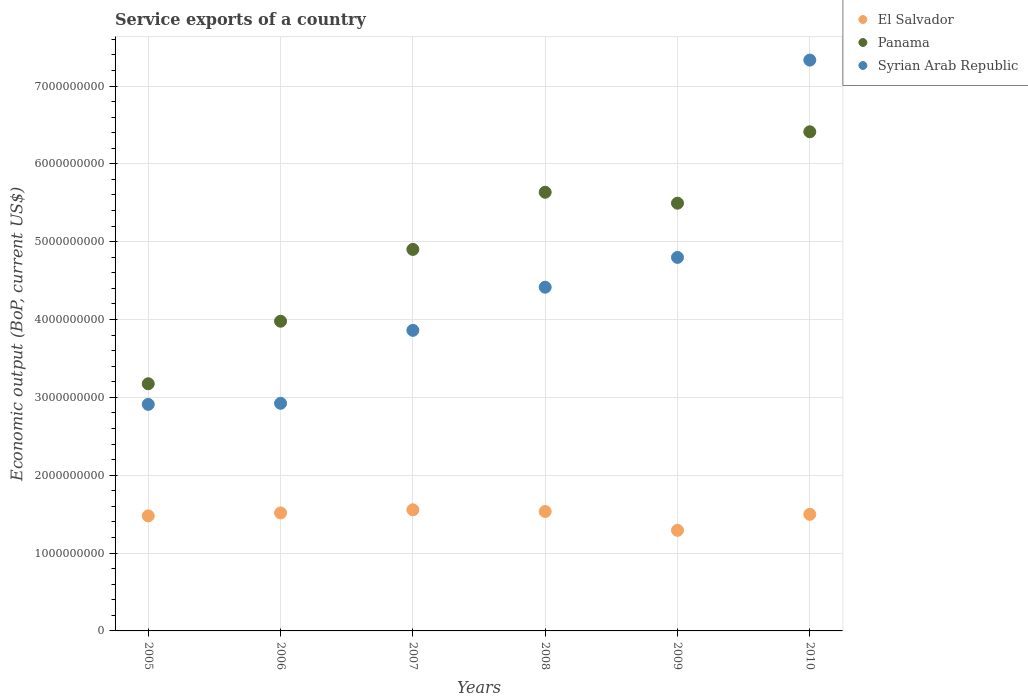Is the number of dotlines equal to the number of legend labels?
Provide a short and direct response. Yes. What is the service exports in Syrian Arab Republic in 2006?
Your response must be concise. 2.92e+09. Across all years, what is the maximum service exports in Syrian Arab Republic?
Keep it short and to the point. 7.33e+09. Across all years, what is the minimum service exports in Panama?
Your answer should be compact. 3.18e+09. What is the total service exports in Panama in the graph?
Keep it short and to the point. 2.96e+1. What is the difference between the service exports in Syrian Arab Republic in 2005 and that in 2010?
Your answer should be very brief. -4.42e+09. What is the difference between the service exports in Syrian Arab Republic in 2006 and the service exports in Panama in 2008?
Keep it short and to the point. -2.71e+09. What is the average service exports in El Salvador per year?
Offer a terse response. 1.48e+09. In the year 2006, what is the difference between the service exports in Syrian Arab Republic and service exports in Panama?
Offer a very short reply. -1.05e+09. What is the ratio of the service exports in Syrian Arab Republic in 2006 to that in 2009?
Keep it short and to the point. 0.61. Is the service exports in Panama in 2005 less than that in 2006?
Keep it short and to the point. Yes. What is the difference between the highest and the second highest service exports in Panama?
Make the answer very short. 7.77e+08. What is the difference between the highest and the lowest service exports in El Salvador?
Offer a very short reply. 2.63e+08. Is the sum of the service exports in Syrian Arab Republic in 2006 and 2008 greater than the maximum service exports in El Salvador across all years?
Your response must be concise. Yes. Does the service exports in El Salvador monotonically increase over the years?
Provide a short and direct response. No. Is the service exports in El Salvador strictly greater than the service exports in Syrian Arab Republic over the years?
Your answer should be very brief. No. Is the service exports in Panama strictly less than the service exports in Syrian Arab Republic over the years?
Keep it short and to the point. No. How many dotlines are there?
Ensure brevity in your answer.  3. What is the difference between two consecutive major ticks on the Y-axis?
Provide a succinct answer. 1.00e+09. Are the values on the major ticks of Y-axis written in scientific E-notation?
Keep it short and to the point. No. How are the legend labels stacked?
Your answer should be compact. Vertical. What is the title of the graph?
Your response must be concise. Service exports of a country. What is the label or title of the Y-axis?
Your answer should be very brief. Economic output (BoP, current US$). What is the Economic output (BoP, current US$) of El Salvador in 2005?
Offer a very short reply. 1.48e+09. What is the Economic output (BoP, current US$) of Panama in 2005?
Ensure brevity in your answer.  3.18e+09. What is the Economic output (BoP, current US$) of Syrian Arab Republic in 2005?
Provide a succinct answer. 2.91e+09. What is the Economic output (BoP, current US$) of El Salvador in 2006?
Provide a succinct answer. 1.52e+09. What is the Economic output (BoP, current US$) of Panama in 2006?
Your answer should be compact. 3.98e+09. What is the Economic output (BoP, current US$) in Syrian Arab Republic in 2006?
Your answer should be very brief. 2.92e+09. What is the Economic output (BoP, current US$) of El Salvador in 2007?
Keep it short and to the point. 1.56e+09. What is the Economic output (BoP, current US$) in Panama in 2007?
Give a very brief answer. 4.90e+09. What is the Economic output (BoP, current US$) in Syrian Arab Republic in 2007?
Provide a short and direct response. 3.86e+09. What is the Economic output (BoP, current US$) in El Salvador in 2008?
Ensure brevity in your answer.  1.53e+09. What is the Economic output (BoP, current US$) of Panama in 2008?
Keep it short and to the point. 5.64e+09. What is the Economic output (BoP, current US$) in Syrian Arab Republic in 2008?
Your response must be concise. 4.42e+09. What is the Economic output (BoP, current US$) in El Salvador in 2009?
Give a very brief answer. 1.29e+09. What is the Economic output (BoP, current US$) of Panama in 2009?
Provide a succinct answer. 5.49e+09. What is the Economic output (BoP, current US$) in Syrian Arab Republic in 2009?
Give a very brief answer. 4.80e+09. What is the Economic output (BoP, current US$) in El Salvador in 2010?
Ensure brevity in your answer.  1.50e+09. What is the Economic output (BoP, current US$) of Panama in 2010?
Your answer should be compact. 6.41e+09. What is the Economic output (BoP, current US$) in Syrian Arab Republic in 2010?
Provide a succinct answer. 7.33e+09. Across all years, what is the maximum Economic output (BoP, current US$) of El Salvador?
Offer a terse response. 1.56e+09. Across all years, what is the maximum Economic output (BoP, current US$) of Panama?
Offer a very short reply. 6.41e+09. Across all years, what is the maximum Economic output (BoP, current US$) of Syrian Arab Republic?
Keep it short and to the point. 7.33e+09. Across all years, what is the minimum Economic output (BoP, current US$) of El Salvador?
Make the answer very short. 1.29e+09. Across all years, what is the minimum Economic output (BoP, current US$) in Panama?
Ensure brevity in your answer.  3.18e+09. Across all years, what is the minimum Economic output (BoP, current US$) in Syrian Arab Republic?
Your response must be concise. 2.91e+09. What is the total Economic output (BoP, current US$) of El Salvador in the graph?
Your response must be concise. 8.87e+09. What is the total Economic output (BoP, current US$) of Panama in the graph?
Your response must be concise. 2.96e+1. What is the total Economic output (BoP, current US$) of Syrian Arab Republic in the graph?
Keep it short and to the point. 2.62e+1. What is the difference between the Economic output (BoP, current US$) of El Salvador in 2005 and that in 2006?
Provide a succinct answer. -3.79e+07. What is the difference between the Economic output (BoP, current US$) in Panama in 2005 and that in 2006?
Your answer should be very brief. -8.03e+08. What is the difference between the Economic output (BoP, current US$) of Syrian Arab Republic in 2005 and that in 2006?
Keep it short and to the point. -1.40e+07. What is the difference between the Economic output (BoP, current US$) of El Salvador in 2005 and that in 2007?
Your answer should be compact. -7.76e+07. What is the difference between the Economic output (BoP, current US$) in Panama in 2005 and that in 2007?
Offer a very short reply. -1.73e+09. What is the difference between the Economic output (BoP, current US$) in Syrian Arab Republic in 2005 and that in 2007?
Offer a very short reply. -9.51e+08. What is the difference between the Economic output (BoP, current US$) of El Salvador in 2005 and that in 2008?
Offer a terse response. -5.62e+07. What is the difference between the Economic output (BoP, current US$) of Panama in 2005 and that in 2008?
Your answer should be very brief. -2.46e+09. What is the difference between the Economic output (BoP, current US$) of Syrian Arab Republic in 2005 and that in 2008?
Give a very brief answer. -1.51e+09. What is the difference between the Economic output (BoP, current US$) of El Salvador in 2005 and that in 2009?
Offer a terse response. 1.86e+08. What is the difference between the Economic output (BoP, current US$) of Panama in 2005 and that in 2009?
Provide a succinct answer. -2.32e+09. What is the difference between the Economic output (BoP, current US$) in Syrian Arab Republic in 2005 and that in 2009?
Keep it short and to the point. -1.89e+09. What is the difference between the Economic output (BoP, current US$) in El Salvador in 2005 and that in 2010?
Give a very brief answer. -1.99e+07. What is the difference between the Economic output (BoP, current US$) of Panama in 2005 and that in 2010?
Your response must be concise. -3.24e+09. What is the difference between the Economic output (BoP, current US$) in Syrian Arab Republic in 2005 and that in 2010?
Your response must be concise. -4.42e+09. What is the difference between the Economic output (BoP, current US$) of El Salvador in 2006 and that in 2007?
Give a very brief answer. -3.97e+07. What is the difference between the Economic output (BoP, current US$) in Panama in 2006 and that in 2007?
Provide a short and direct response. -9.22e+08. What is the difference between the Economic output (BoP, current US$) of Syrian Arab Republic in 2006 and that in 2007?
Your answer should be very brief. -9.37e+08. What is the difference between the Economic output (BoP, current US$) of El Salvador in 2006 and that in 2008?
Your response must be concise. -1.83e+07. What is the difference between the Economic output (BoP, current US$) in Panama in 2006 and that in 2008?
Your answer should be very brief. -1.66e+09. What is the difference between the Economic output (BoP, current US$) of Syrian Arab Republic in 2006 and that in 2008?
Your answer should be very brief. -1.49e+09. What is the difference between the Economic output (BoP, current US$) in El Salvador in 2006 and that in 2009?
Ensure brevity in your answer.  2.24e+08. What is the difference between the Economic output (BoP, current US$) of Panama in 2006 and that in 2009?
Ensure brevity in your answer.  -1.52e+09. What is the difference between the Economic output (BoP, current US$) in Syrian Arab Republic in 2006 and that in 2009?
Your answer should be very brief. -1.87e+09. What is the difference between the Economic output (BoP, current US$) in El Salvador in 2006 and that in 2010?
Your answer should be very brief. 1.80e+07. What is the difference between the Economic output (BoP, current US$) of Panama in 2006 and that in 2010?
Make the answer very short. -2.43e+09. What is the difference between the Economic output (BoP, current US$) in Syrian Arab Republic in 2006 and that in 2010?
Provide a succinct answer. -4.41e+09. What is the difference between the Economic output (BoP, current US$) of El Salvador in 2007 and that in 2008?
Provide a succinct answer. 2.14e+07. What is the difference between the Economic output (BoP, current US$) in Panama in 2007 and that in 2008?
Your answer should be very brief. -7.34e+08. What is the difference between the Economic output (BoP, current US$) of Syrian Arab Republic in 2007 and that in 2008?
Give a very brief answer. -5.54e+08. What is the difference between the Economic output (BoP, current US$) in El Salvador in 2007 and that in 2009?
Give a very brief answer. 2.63e+08. What is the difference between the Economic output (BoP, current US$) of Panama in 2007 and that in 2009?
Provide a succinct answer. -5.94e+08. What is the difference between the Economic output (BoP, current US$) of Syrian Arab Republic in 2007 and that in 2009?
Offer a very short reply. -9.37e+08. What is the difference between the Economic output (BoP, current US$) in El Salvador in 2007 and that in 2010?
Offer a terse response. 5.77e+07. What is the difference between the Economic output (BoP, current US$) in Panama in 2007 and that in 2010?
Offer a very short reply. -1.51e+09. What is the difference between the Economic output (BoP, current US$) of Syrian Arab Republic in 2007 and that in 2010?
Give a very brief answer. -3.47e+09. What is the difference between the Economic output (BoP, current US$) of El Salvador in 2008 and that in 2009?
Offer a terse response. 2.42e+08. What is the difference between the Economic output (BoP, current US$) in Panama in 2008 and that in 2009?
Your response must be concise. 1.40e+08. What is the difference between the Economic output (BoP, current US$) of Syrian Arab Republic in 2008 and that in 2009?
Offer a very short reply. -3.83e+08. What is the difference between the Economic output (BoP, current US$) of El Salvador in 2008 and that in 2010?
Offer a very short reply. 3.63e+07. What is the difference between the Economic output (BoP, current US$) in Panama in 2008 and that in 2010?
Give a very brief answer. -7.77e+08. What is the difference between the Economic output (BoP, current US$) of Syrian Arab Republic in 2008 and that in 2010?
Offer a very short reply. -2.92e+09. What is the difference between the Economic output (BoP, current US$) in El Salvador in 2009 and that in 2010?
Make the answer very short. -2.06e+08. What is the difference between the Economic output (BoP, current US$) in Panama in 2009 and that in 2010?
Provide a succinct answer. -9.17e+08. What is the difference between the Economic output (BoP, current US$) of Syrian Arab Republic in 2009 and that in 2010?
Keep it short and to the point. -2.53e+09. What is the difference between the Economic output (BoP, current US$) in El Salvador in 2005 and the Economic output (BoP, current US$) in Panama in 2006?
Provide a succinct answer. -2.50e+09. What is the difference between the Economic output (BoP, current US$) in El Salvador in 2005 and the Economic output (BoP, current US$) in Syrian Arab Republic in 2006?
Provide a short and direct response. -1.45e+09. What is the difference between the Economic output (BoP, current US$) in Panama in 2005 and the Economic output (BoP, current US$) in Syrian Arab Republic in 2006?
Provide a short and direct response. 2.51e+08. What is the difference between the Economic output (BoP, current US$) in El Salvador in 2005 and the Economic output (BoP, current US$) in Panama in 2007?
Make the answer very short. -3.42e+09. What is the difference between the Economic output (BoP, current US$) of El Salvador in 2005 and the Economic output (BoP, current US$) of Syrian Arab Republic in 2007?
Make the answer very short. -2.38e+09. What is the difference between the Economic output (BoP, current US$) of Panama in 2005 and the Economic output (BoP, current US$) of Syrian Arab Republic in 2007?
Keep it short and to the point. -6.86e+08. What is the difference between the Economic output (BoP, current US$) in El Salvador in 2005 and the Economic output (BoP, current US$) in Panama in 2008?
Make the answer very short. -4.16e+09. What is the difference between the Economic output (BoP, current US$) of El Salvador in 2005 and the Economic output (BoP, current US$) of Syrian Arab Republic in 2008?
Offer a very short reply. -2.94e+09. What is the difference between the Economic output (BoP, current US$) in Panama in 2005 and the Economic output (BoP, current US$) in Syrian Arab Republic in 2008?
Offer a very short reply. -1.24e+09. What is the difference between the Economic output (BoP, current US$) of El Salvador in 2005 and the Economic output (BoP, current US$) of Panama in 2009?
Give a very brief answer. -4.02e+09. What is the difference between the Economic output (BoP, current US$) in El Salvador in 2005 and the Economic output (BoP, current US$) in Syrian Arab Republic in 2009?
Ensure brevity in your answer.  -3.32e+09. What is the difference between the Economic output (BoP, current US$) in Panama in 2005 and the Economic output (BoP, current US$) in Syrian Arab Republic in 2009?
Ensure brevity in your answer.  -1.62e+09. What is the difference between the Economic output (BoP, current US$) in El Salvador in 2005 and the Economic output (BoP, current US$) in Panama in 2010?
Offer a terse response. -4.93e+09. What is the difference between the Economic output (BoP, current US$) of El Salvador in 2005 and the Economic output (BoP, current US$) of Syrian Arab Republic in 2010?
Offer a terse response. -5.86e+09. What is the difference between the Economic output (BoP, current US$) of Panama in 2005 and the Economic output (BoP, current US$) of Syrian Arab Republic in 2010?
Your response must be concise. -4.16e+09. What is the difference between the Economic output (BoP, current US$) in El Salvador in 2006 and the Economic output (BoP, current US$) in Panama in 2007?
Offer a terse response. -3.38e+09. What is the difference between the Economic output (BoP, current US$) in El Salvador in 2006 and the Economic output (BoP, current US$) in Syrian Arab Republic in 2007?
Keep it short and to the point. -2.35e+09. What is the difference between the Economic output (BoP, current US$) in Panama in 2006 and the Economic output (BoP, current US$) in Syrian Arab Republic in 2007?
Your response must be concise. 1.17e+08. What is the difference between the Economic output (BoP, current US$) in El Salvador in 2006 and the Economic output (BoP, current US$) in Panama in 2008?
Offer a terse response. -4.12e+09. What is the difference between the Economic output (BoP, current US$) in El Salvador in 2006 and the Economic output (BoP, current US$) in Syrian Arab Republic in 2008?
Keep it short and to the point. -2.90e+09. What is the difference between the Economic output (BoP, current US$) in Panama in 2006 and the Economic output (BoP, current US$) in Syrian Arab Republic in 2008?
Provide a short and direct response. -4.37e+08. What is the difference between the Economic output (BoP, current US$) of El Salvador in 2006 and the Economic output (BoP, current US$) of Panama in 2009?
Provide a short and direct response. -3.98e+09. What is the difference between the Economic output (BoP, current US$) of El Salvador in 2006 and the Economic output (BoP, current US$) of Syrian Arab Republic in 2009?
Your response must be concise. -3.28e+09. What is the difference between the Economic output (BoP, current US$) in Panama in 2006 and the Economic output (BoP, current US$) in Syrian Arab Republic in 2009?
Provide a short and direct response. -8.20e+08. What is the difference between the Economic output (BoP, current US$) in El Salvador in 2006 and the Economic output (BoP, current US$) in Panama in 2010?
Make the answer very short. -4.90e+09. What is the difference between the Economic output (BoP, current US$) of El Salvador in 2006 and the Economic output (BoP, current US$) of Syrian Arab Republic in 2010?
Provide a succinct answer. -5.82e+09. What is the difference between the Economic output (BoP, current US$) in Panama in 2006 and the Economic output (BoP, current US$) in Syrian Arab Republic in 2010?
Offer a terse response. -3.35e+09. What is the difference between the Economic output (BoP, current US$) of El Salvador in 2007 and the Economic output (BoP, current US$) of Panama in 2008?
Offer a very short reply. -4.08e+09. What is the difference between the Economic output (BoP, current US$) in El Salvador in 2007 and the Economic output (BoP, current US$) in Syrian Arab Republic in 2008?
Offer a terse response. -2.86e+09. What is the difference between the Economic output (BoP, current US$) in Panama in 2007 and the Economic output (BoP, current US$) in Syrian Arab Republic in 2008?
Your response must be concise. 4.86e+08. What is the difference between the Economic output (BoP, current US$) of El Salvador in 2007 and the Economic output (BoP, current US$) of Panama in 2009?
Your answer should be compact. -3.94e+09. What is the difference between the Economic output (BoP, current US$) in El Salvador in 2007 and the Economic output (BoP, current US$) in Syrian Arab Republic in 2009?
Offer a terse response. -3.24e+09. What is the difference between the Economic output (BoP, current US$) in Panama in 2007 and the Economic output (BoP, current US$) in Syrian Arab Republic in 2009?
Make the answer very short. 1.02e+08. What is the difference between the Economic output (BoP, current US$) of El Salvador in 2007 and the Economic output (BoP, current US$) of Panama in 2010?
Provide a succinct answer. -4.86e+09. What is the difference between the Economic output (BoP, current US$) in El Salvador in 2007 and the Economic output (BoP, current US$) in Syrian Arab Republic in 2010?
Make the answer very short. -5.78e+09. What is the difference between the Economic output (BoP, current US$) in Panama in 2007 and the Economic output (BoP, current US$) in Syrian Arab Republic in 2010?
Provide a short and direct response. -2.43e+09. What is the difference between the Economic output (BoP, current US$) in El Salvador in 2008 and the Economic output (BoP, current US$) in Panama in 2009?
Offer a very short reply. -3.96e+09. What is the difference between the Economic output (BoP, current US$) in El Salvador in 2008 and the Economic output (BoP, current US$) in Syrian Arab Republic in 2009?
Your answer should be compact. -3.26e+09. What is the difference between the Economic output (BoP, current US$) of Panama in 2008 and the Economic output (BoP, current US$) of Syrian Arab Republic in 2009?
Ensure brevity in your answer.  8.37e+08. What is the difference between the Economic output (BoP, current US$) in El Salvador in 2008 and the Economic output (BoP, current US$) in Panama in 2010?
Offer a very short reply. -4.88e+09. What is the difference between the Economic output (BoP, current US$) in El Salvador in 2008 and the Economic output (BoP, current US$) in Syrian Arab Republic in 2010?
Ensure brevity in your answer.  -5.80e+09. What is the difference between the Economic output (BoP, current US$) in Panama in 2008 and the Economic output (BoP, current US$) in Syrian Arab Republic in 2010?
Your answer should be compact. -1.70e+09. What is the difference between the Economic output (BoP, current US$) in El Salvador in 2009 and the Economic output (BoP, current US$) in Panama in 2010?
Keep it short and to the point. -5.12e+09. What is the difference between the Economic output (BoP, current US$) in El Salvador in 2009 and the Economic output (BoP, current US$) in Syrian Arab Republic in 2010?
Offer a terse response. -6.04e+09. What is the difference between the Economic output (BoP, current US$) of Panama in 2009 and the Economic output (BoP, current US$) of Syrian Arab Republic in 2010?
Provide a short and direct response. -1.84e+09. What is the average Economic output (BoP, current US$) in El Salvador per year?
Your answer should be compact. 1.48e+09. What is the average Economic output (BoP, current US$) of Panama per year?
Your answer should be very brief. 4.93e+09. What is the average Economic output (BoP, current US$) in Syrian Arab Republic per year?
Offer a terse response. 4.37e+09. In the year 2005, what is the difference between the Economic output (BoP, current US$) of El Salvador and Economic output (BoP, current US$) of Panama?
Offer a very short reply. -1.70e+09. In the year 2005, what is the difference between the Economic output (BoP, current US$) in El Salvador and Economic output (BoP, current US$) in Syrian Arab Republic?
Give a very brief answer. -1.43e+09. In the year 2005, what is the difference between the Economic output (BoP, current US$) of Panama and Economic output (BoP, current US$) of Syrian Arab Republic?
Your answer should be compact. 2.65e+08. In the year 2006, what is the difference between the Economic output (BoP, current US$) of El Salvador and Economic output (BoP, current US$) of Panama?
Offer a very short reply. -2.46e+09. In the year 2006, what is the difference between the Economic output (BoP, current US$) of El Salvador and Economic output (BoP, current US$) of Syrian Arab Republic?
Make the answer very short. -1.41e+09. In the year 2006, what is the difference between the Economic output (BoP, current US$) in Panama and Economic output (BoP, current US$) in Syrian Arab Republic?
Your answer should be compact. 1.05e+09. In the year 2007, what is the difference between the Economic output (BoP, current US$) of El Salvador and Economic output (BoP, current US$) of Panama?
Your answer should be very brief. -3.35e+09. In the year 2007, what is the difference between the Economic output (BoP, current US$) in El Salvador and Economic output (BoP, current US$) in Syrian Arab Republic?
Keep it short and to the point. -2.31e+09. In the year 2007, what is the difference between the Economic output (BoP, current US$) of Panama and Economic output (BoP, current US$) of Syrian Arab Republic?
Give a very brief answer. 1.04e+09. In the year 2008, what is the difference between the Economic output (BoP, current US$) in El Salvador and Economic output (BoP, current US$) in Panama?
Keep it short and to the point. -4.10e+09. In the year 2008, what is the difference between the Economic output (BoP, current US$) in El Salvador and Economic output (BoP, current US$) in Syrian Arab Republic?
Your response must be concise. -2.88e+09. In the year 2008, what is the difference between the Economic output (BoP, current US$) in Panama and Economic output (BoP, current US$) in Syrian Arab Republic?
Offer a very short reply. 1.22e+09. In the year 2009, what is the difference between the Economic output (BoP, current US$) in El Salvador and Economic output (BoP, current US$) in Panama?
Ensure brevity in your answer.  -4.20e+09. In the year 2009, what is the difference between the Economic output (BoP, current US$) of El Salvador and Economic output (BoP, current US$) of Syrian Arab Republic?
Your answer should be compact. -3.51e+09. In the year 2009, what is the difference between the Economic output (BoP, current US$) of Panama and Economic output (BoP, current US$) of Syrian Arab Republic?
Ensure brevity in your answer.  6.96e+08. In the year 2010, what is the difference between the Economic output (BoP, current US$) in El Salvador and Economic output (BoP, current US$) in Panama?
Keep it short and to the point. -4.91e+09. In the year 2010, what is the difference between the Economic output (BoP, current US$) in El Salvador and Economic output (BoP, current US$) in Syrian Arab Republic?
Your response must be concise. -5.84e+09. In the year 2010, what is the difference between the Economic output (BoP, current US$) in Panama and Economic output (BoP, current US$) in Syrian Arab Republic?
Give a very brief answer. -9.21e+08. What is the ratio of the Economic output (BoP, current US$) of El Salvador in 2005 to that in 2006?
Make the answer very short. 0.97. What is the ratio of the Economic output (BoP, current US$) of Panama in 2005 to that in 2006?
Keep it short and to the point. 0.8. What is the ratio of the Economic output (BoP, current US$) in Syrian Arab Republic in 2005 to that in 2006?
Offer a very short reply. 1. What is the ratio of the Economic output (BoP, current US$) in El Salvador in 2005 to that in 2007?
Make the answer very short. 0.95. What is the ratio of the Economic output (BoP, current US$) in Panama in 2005 to that in 2007?
Give a very brief answer. 0.65. What is the ratio of the Economic output (BoP, current US$) of Syrian Arab Republic in 2005 to that in 2007?
Make the answer very short. 0.75. What is the ratio of the Economic output (BoP, current US$) of El Salvador in 2005 to that in 2008?
Provide a succinct answer. 0.96. What is the ratio of the Economic output (BoP, current US$) of Panama in 2005 to that in 2008?
Offer a very short reply. 0.56. What is the ratio of the Economic output (BoP, current US$) in Syrian Arab Republic in 2005 to that in 2008?
Your response must be concise. 0.66. What is the ratio of the Economic output (BoP, current US$) of El Salvador in 2005 to that in 2009?
Your answer should be very brief. 1.14. What is the ratio of the Economic output (BoP, current US$) of Panama in 2005 to that in 2009?
Offer a very short reply. 0.58. What is the ratio of the Economic output (BoP, current US$) in Syrian Arab Republic in 2005 to that in 2009?
Give a very brief answer. 0.61. What is the ratio of the Economic output (BoP, current US$) in El Salvador in 2005 to that in 2010?
Offer a terse response. 0.99. What is the ratio of the Economic output (BoP, current US$) in Panama in 2005 to that in 2010?
Your answer should be compact. 0.5. What is the ratio of the Economic output (BoP, current US$) in Syrian Arab Republic in 2005 to that in 2010?
Make the answer very short. 0.4. What is the ratio of the Economic output (BoP, current US$) in El Salvador in 2006 to that in 2007?
Provide a succinct answer. 0.97. What is the ratio of the Economic output (BoP, current US$) of Panama in 2006 to that in 2007?
Your answer should be very brief. 0.81. What is the ratio of the Economic output (BoP, current US$) in Syrian Arab Republic in 2006 to that in 2007?
Keep it short and to the point. 0.76. What is the ratio of the Economic output (BoP, current US$) in Panama in 2006 to that in 2008?
Ensure brevity in your answer.  0.71. What is the ratio of the Economic output (BoP, current US$) of Syrian Arab Republic in 2006 to that in 2008?
Offer a very short reply. 0.66. What is the ratio of the Economic output (BoP, current US$) in El Salvador in 2006 to that in 2009?
Make the answer very short. 1.17. What is the ratio of the Economic output (BoP, current US$) in Panama in 2006 to that in 2009?
Provide a succinct answer. 0.72. What is the ratio of the Economic output (BoP, current US$) of Syrian Arab Republic in 2006 to that in 2009?
Keep it short and to the point. 0.61. What is the ratio of the Economic output (BoP, current US$) of El Salvador in 2006 to that in 2010?
Provide a succinct answer. 1.01. What is the ratio of the Economic output (BoP, current US$) in Panama in 2006 to that in 2010?
Provide a succinct answer. 0.62. What is the ratio of the Economic output (BoP, current US$) of Syrian Arab Republic in 2006 to that in 2010?
Provide a succinct answer. 0.4. What is the ratio of the Economic output (BoP, current US$) of El Salvador in 2007 to that in 2008?
Offer a terse response. 1.01. What is the ratio of the Economic output (BoP, current US$) of Panama in 2007 to that in 2008?
Offer a very short reply. 0.87. What is the ratio of the Economic output (BoP, current US$) in Syrian Arab Republic in 2007 to that in 2008?
Your answer should be compact. 0.87. What is the ratio of the Economic output (BoP, current US$) of El Salvador in 2007 to that in 2009?
Make the answer very short. 1.2. What is the ratio of the Economic output (BoP, current US$) in Panama in 2007 to that in 2009?
Offer a very short reply. 0.89. What is the ratio of the Economic output (BoP, current US$) of Syrian Arab Republic in 2007 to that in 2009?
Your answer should be very brief. 0.8. What is the ratio of the Economic output (BoP, current US$) of El Salvador in 2007 to that in 2010?
Give a very brief answer. 1.04. What is the ratio of the Economic output (BoP, current US$) in Panama in 2007 to that in 2010?
Ensure brevity in your answer.  0.76. What is the ratio of the Economic output (BoP, current US$) in Syrian Arab Republic in 2007 to that in 2010?
Offer a terse response. 0.53. What is the ratio of the Economic output (BoP, current US$) of El Salvador in 2008 to that in 2009?
Your answer should be compact. 1.19. What is the ratio of the Economic output (BoP, current US$) in Panama in 2008 to that in 2009?
Make the answer very short. 1.03. What is the ratio of the Economic output (BoP, current US$) in Syrian Arab Republic in 2008 to that in 2009?
Your answer should be very brief. 0.92. What is the ratio of the Economic output (BoP, current US$) in El Salvador in 2008 to that in 2010?
Provide a short and direct response. 1.02. What is the ratio of the Economic output (BoP, current US$) of Panama in 2008 to that in 2010?
Your answer should be very brief. 0.88. What is the ratio of the Economic output (BoP, current US$) in Syrian Arab Republic in 2008 to that in 2010?
Provide a short and direct response. 0.6. What is the ratio of the Economic output (BoP, current US$) in El Salvador in 2009 to that in 2010?
Keep it short and to the point. 0.86. What is the ratio of the Economic output (BoP, current US$) in Panama in 2009 to that in 2010?
Offer a very short reply. 0.86. What is the ratio of the Economic output (BoP, current US$) in Syrian Arab Republic in 2009 to that in 2010?
Offer a very short reply. 0.65. What is the difference between the highest and the second highest Economic output (BoP, current US$) in El Salvador?
Your response must be concise. 2.14e+07. What is the difference between the highest and the second highest Economic output (BoP, current US$) in Panama?
Make the answer very short. 7.77e+08. What is the difference between the highest and the second highest Economic output (BoP, current US$) in Syrian Arab Republic?
Make the answer very short. 2.53e+09. What is the difference between the highest and the lowest Economic output (BoP, current US$) in El Salvador?
Ensure brevity in your answer.  2.63e+08. What is the difference between the highest and the lowest Economic output (BoP, current US$) in Panama?
Ensure brevity in your answer.  3.24e+09. What is the difference between the highest and the lowest Economic output (BoP, current US$) of Syrian Arab Republic?
Offer a terse response. 4.42e+09. 